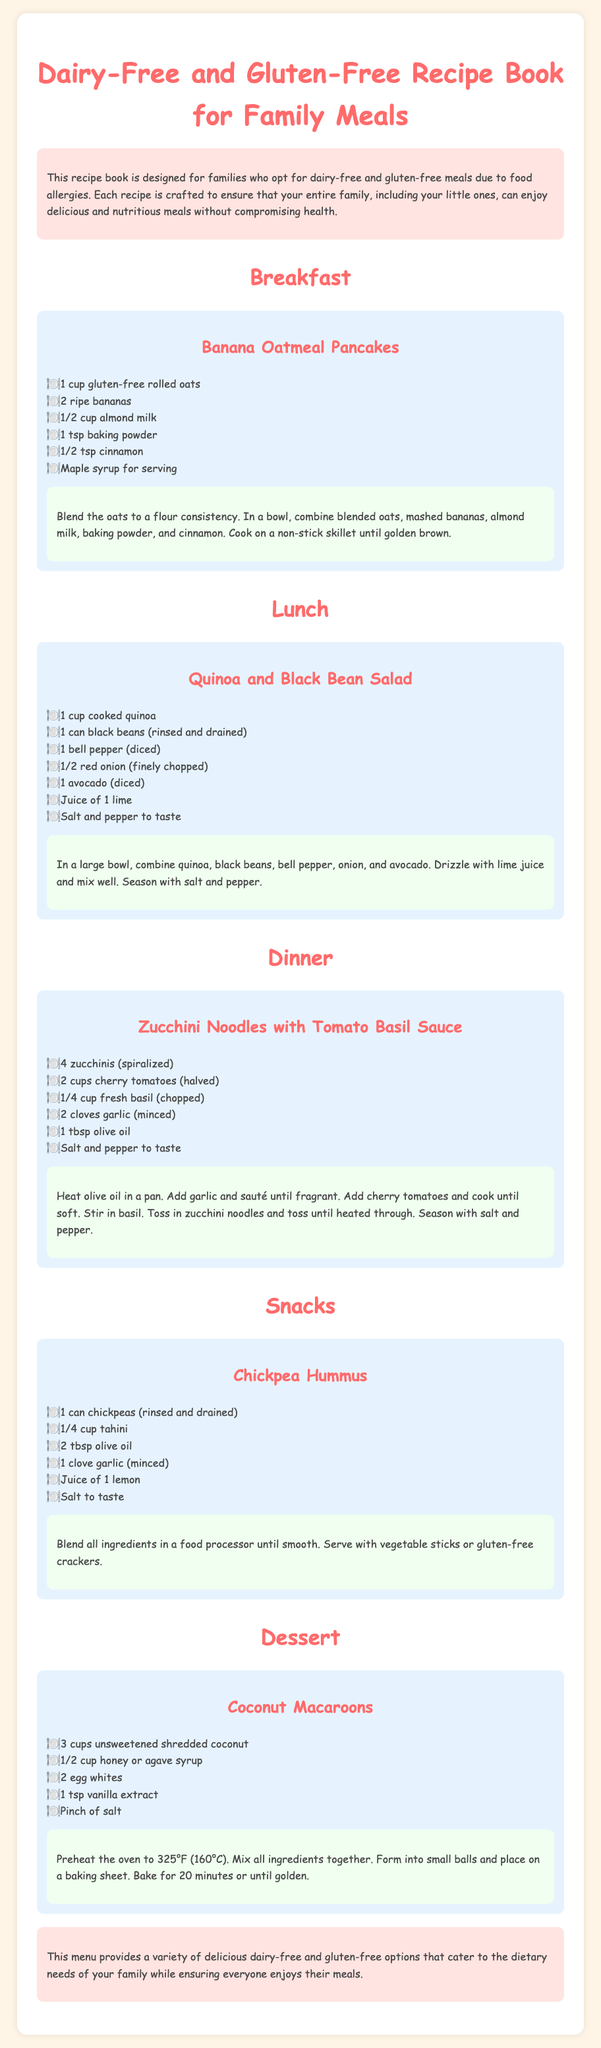What are the ingredients in the Banana Oatmeal Pancakes? The ingredients listed for the Banana Oatmeal Pancakes include 1 cup gluten-free rolled oats, 2 ripe bananas, 1/2 cup almond milk, 1 tsp baking powder, and 1/2 tsp cinnamon.
Answer: 1 cup gluten-free rolled oats, 2 ripe bananas, 1/2 cup almond milk, 1 tsp baking powder, 1/2 tsp cinnamon What is the main protein source in the Quinoa and Black Bean Salad? The main protein source in the Quinoa and Black Bean Salad is the black beans listed as one of the ingredients.
Answer: Black beans How many zucchinis are required for the Zucchini Noodles with Tomato Basil Sauce? The recipe for Zucchini Noodles with Tomato Basil Sauce specifies using 4 zucchinis, which are spiralized.
Answer: 4 zucchinis How long should the Coconut Macaroons bake? The document states that the Coconut Macaroons should bake for 20 minutes or until golden.
Answer: 20 minutes What type of milk is used in the Banana Oatmeal Pancakes? The recipe for Banana Oatmeal Pancakes uses almond milk as the dairy-free alternative.
Answer: Almond milk Which meal type includes a recipe for snacks? The document includes a section for snacks, which contains the Chickpea Hummus recipe.
Answer: Snacks What is the total number of main meals listed in the document? There are five main meal types listed in the document: Breakfast, Lunch, Dinner, Snacks, and Dessert.
Answer: Five What spice is used in the Banana Oatmeal Pancakes? The spice listed in the Banana Oatmeal Pancakes recipe is cinnamon.
Answer: Cinnamon Which ingredient is common in both the Chickpea Hummus and the Zucchini Noodles recipes? Olive oil is listed as an ingredient in both the Chickpea Hummus and Zucchini Noodles with Tomato Basil Sauce recipes.
Answer: Olive oil 